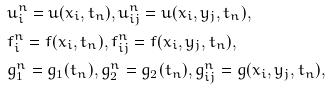Convert formula to latex. <formula><loc_0><loc_0><loc_500><loc_500>& u _ { i } ^ { n } = u ( x _ { i } , t _ { n } ) , u _ { i j } ^ { n } = u ( x _ { i } , y _ { j } , t _ { n } ) , \\ & f ^ { n } _ { i } = f ( x _ { i } , t _ { n } ) , f ^ { n } _ { i j } = f ( x _ { i } , y _ { j } , t _ { n } ) , \\ & g _ { 1 } ^ { n } = g _ { 1 } ( t _ { n } ) , g _ { 2 } ^ { n } = g _ { 2 } ( t _ { n } ) , g _ { i j } ^ { n } = g ( x _ { i } , y _ { j } , t _ { n } ) ,</formula> 